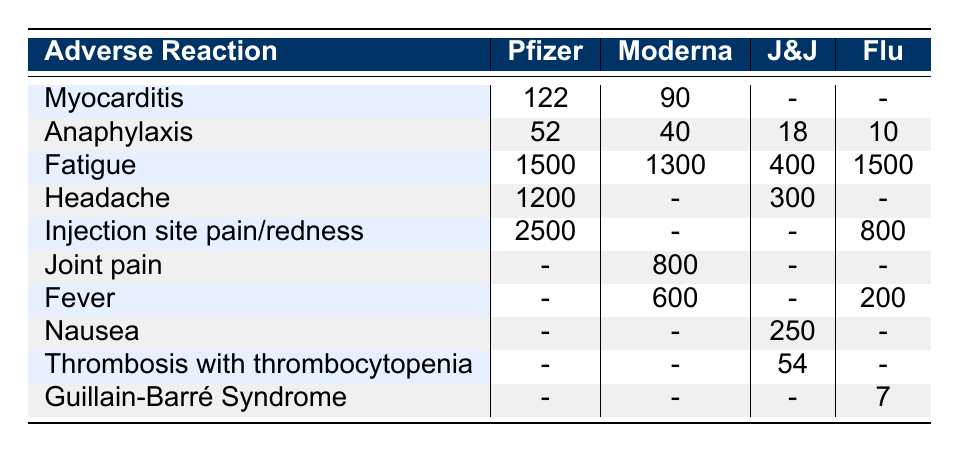What is the reported number of cases of Myocarditis for the Pfizer vaccine? The table indicates that there are 122 reported cases of Myocarditis for the Pfizer-BioNTech COVID-19 Vaccine.
Answer: 122 Which vaccine had the highest number of reported cases for Injection site pain/redness? According to the table, the Pfizer vaccine has the highest number of reported cases for Injection site pain at 2500.
Answer: Pfizer Is there any reported case of Guillain-Barré Syndrome for the Moderna vaccine? The table shows that there are no reported cases of Guillain-Barré Syndrome for the Moderna vaccine.
Answer: No What is the total number of cases reported for Fatigue across all vaccines? Summing the reported cases of Fatigue for all vaccines: 1500 (Pfizer) + 1300 (Moderna) + 400 (Johnson & Johnson) + 1500 (Flu) = 3700.
Answer: 3700 How many more cases of Anaphylaxis were reported for the Pfizer vaccine compared to the Johnson & Johnson vaccine? The Pfizer vaccine has 52 reported cases of Anaphylaxis and the Johnson & Johnson vaccine has 18. The difference is 52 - 18 = 34.
Answer: 34 Which vaccine reported the least cases of Fever? The Flu vaccine has the least cases of Fever, with 200 reported cases, while the others (Moderna and Pfizer) have more.
Answer: Flu Are there any vaccines that reported cases of Joint pain? The table indicates that only the Moderna vaccine reported cases of Joint pain, with a total of 800 cases.
Answer: Yes Which adverse reaction had the most reported cases overall in the table? By comparing the reported cases across all adverse reactions for each vaccine, Injection site pain/soreness has the most reported cases at 2500 for the Pfizer vaccine.
Answer: Injection site pain Which vaccine was associated with the highest rate of Anaphylaxis? The highest number of Anaphylaxis cases was reported for the Pfizer vaccine, with 52 cases compared to 40 for Moderna, 18 for Johnson & Johnson, and 10 for Flu.
Answer: Pfizer 